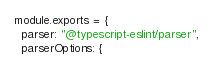Convert code to text. <code><loc_0><loc_0><loc_500><loc_500><_JavaScript_>module.exports = {
  parser: "@typescript-eslint/parser",
  parserOptions: {</code> 